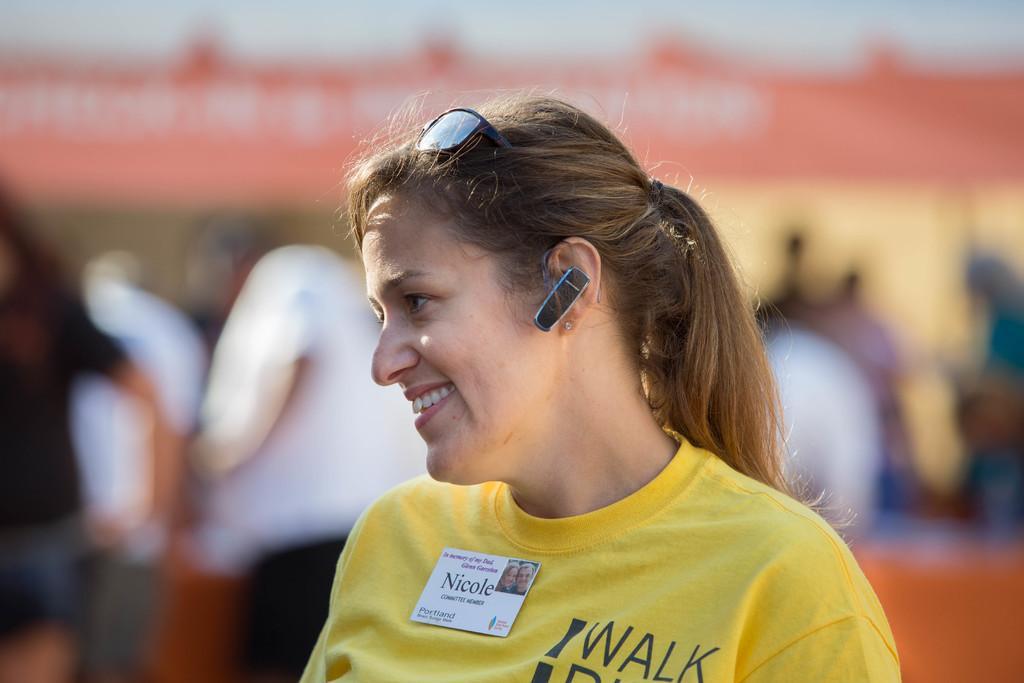How would you summarize this image in a sentence or two? In this image there is a woman with yellow shirt and a batch. There is a Bluetooth in her ear. There are people in the background. It is blurry in the background. 